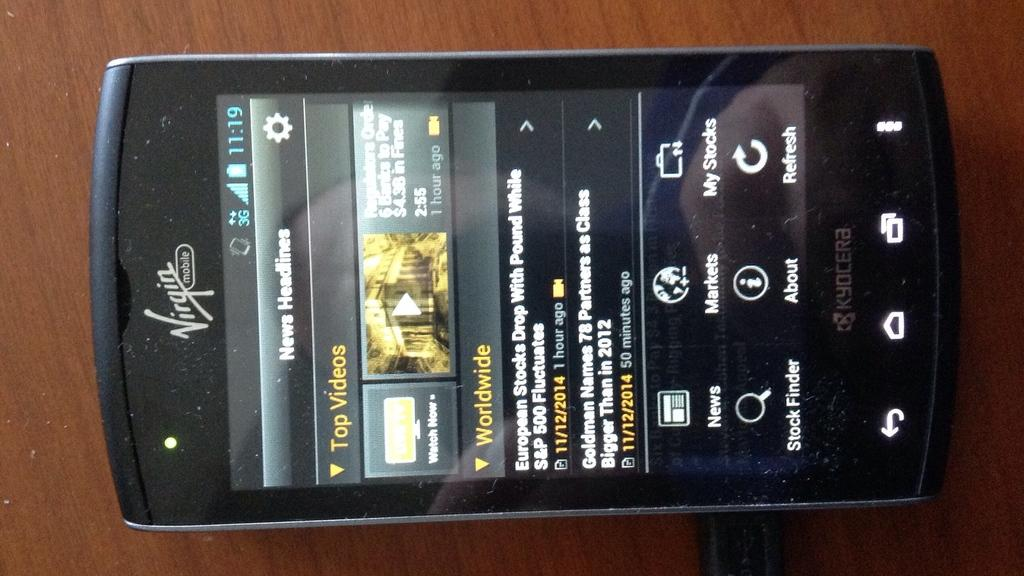<image>
Write a terse but informative summary of the picture. a phone screen with a window open to a website with a Top Videos tab 